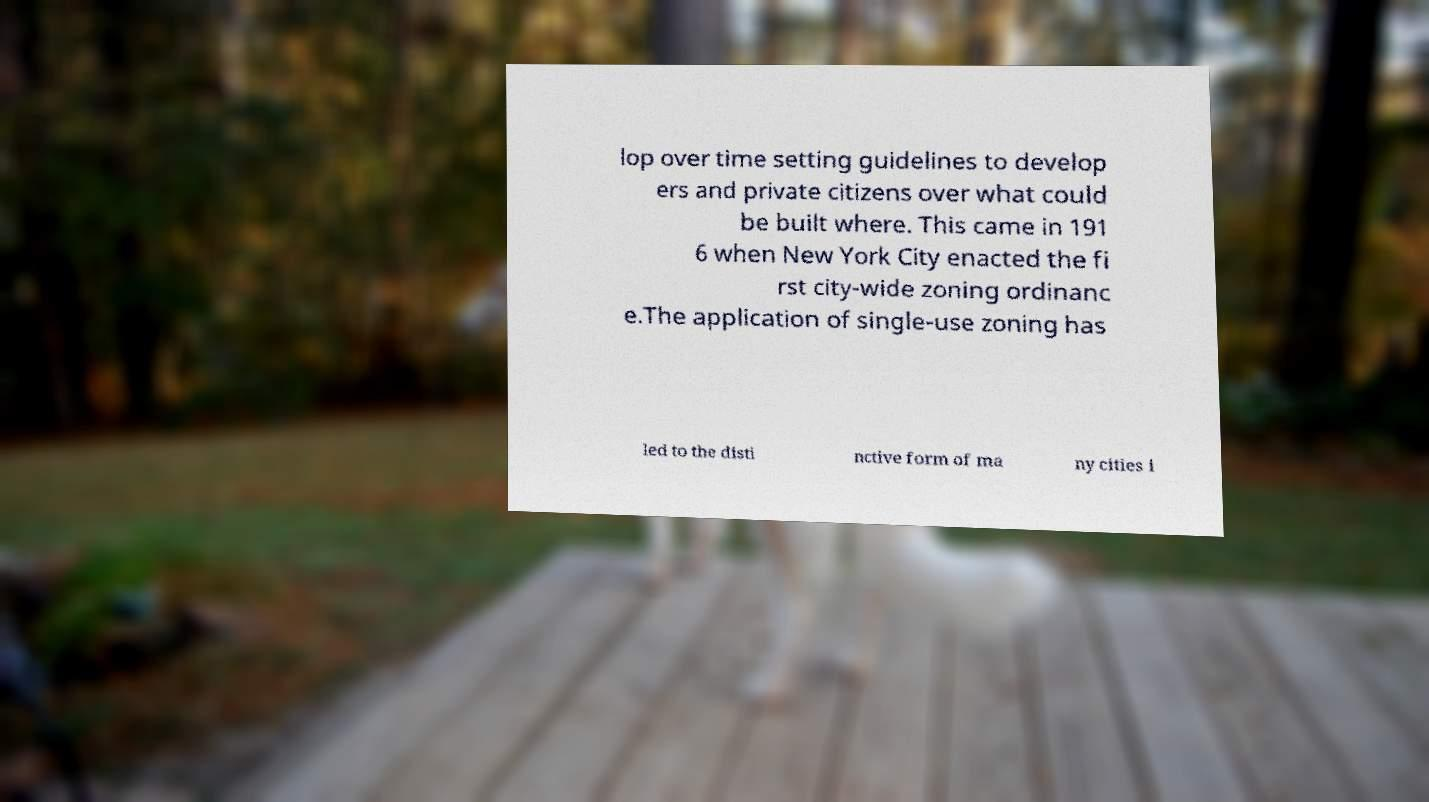Please read and relay the text visible in this image. What does it say? lop over time setting guidelines to develop ers and private citizens over what could be built where. This came in 191 6 when New York City enacted the fi rst city-wide zoning ordinanc e.The application of single-use zoning has led to the disti nctive form of ma ny cities i 